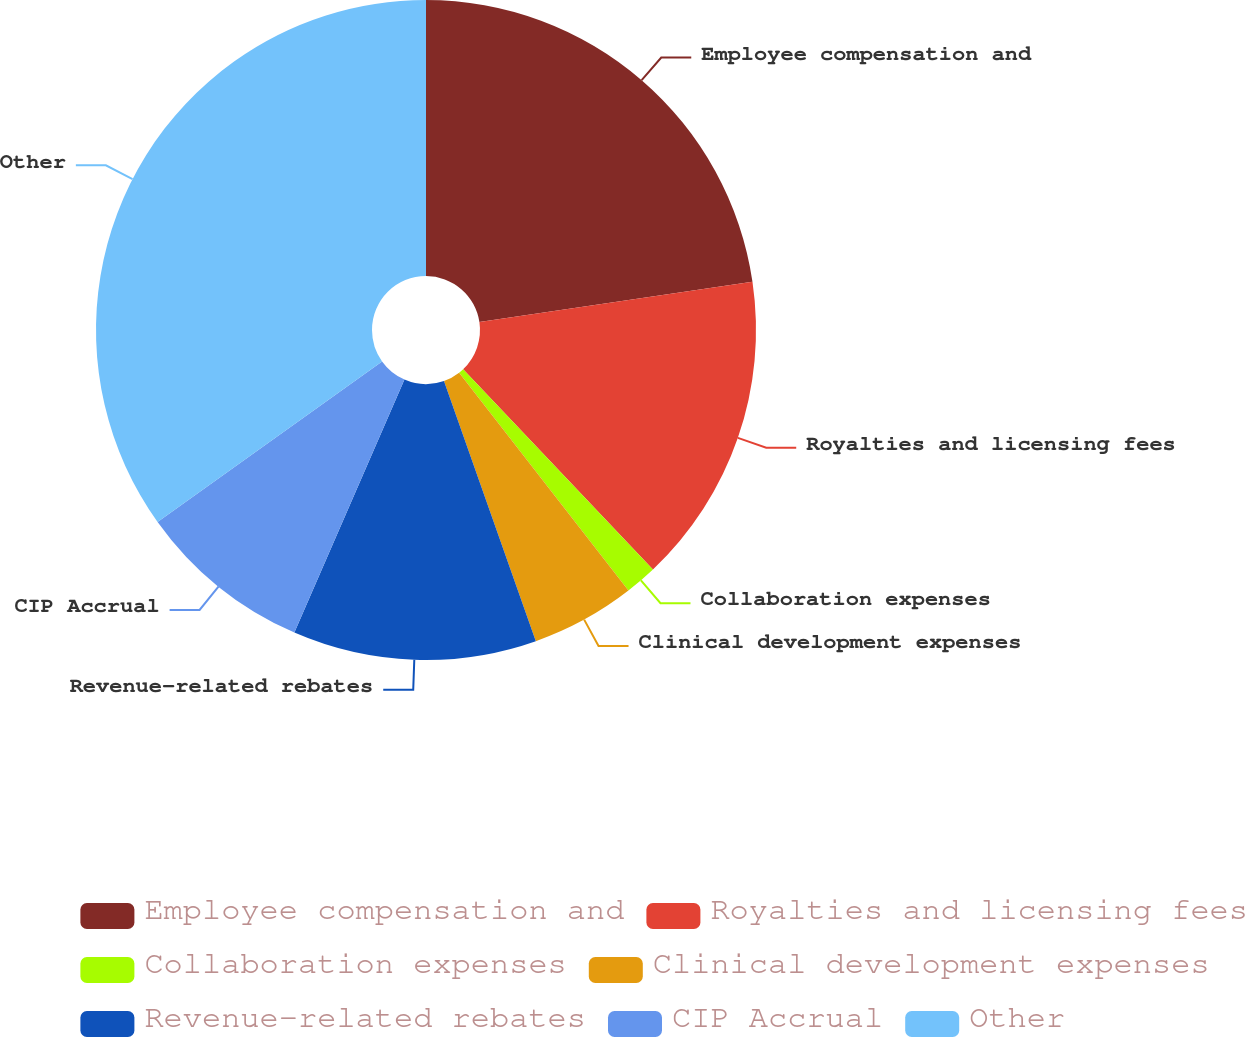Convert chart. <chart><loc_0><loc_0><loc_500><loc_500><pie_chart><fcel>Employee compensation and<fcel>Royalties and licensing fees<fcel>Collaboration expenses<fcel>Clinical development expenses<fcel>Revenue-related rebates<fcel>CIP Accrual<fcel>Other<nl><fcel>22.67%<fcel>15.26%<fcel>1.56%<fcel>5.11%<fcel>11.93%<fcel>8.59%<fcel>34.88%<nl></chart> 